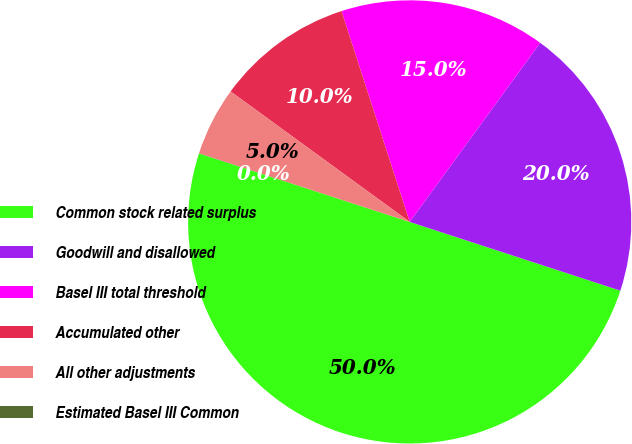Convert chart. <chart><loc_0><loc_0><loc_500><loc_500><pie_chart><fcel>Common stock related surplus<fcel>Goodwill and disallowed<fcel>Basel III total threshold<fcel>Accumulated other<fcel>All other adjustments<fcel>Estimated Basel III Common<nl><fcel>49.98%<fcel>20.0%<fcel>15.0%<fcel>10.0%<fcel>5.01%<fcel>0.01%<nl></chart> 